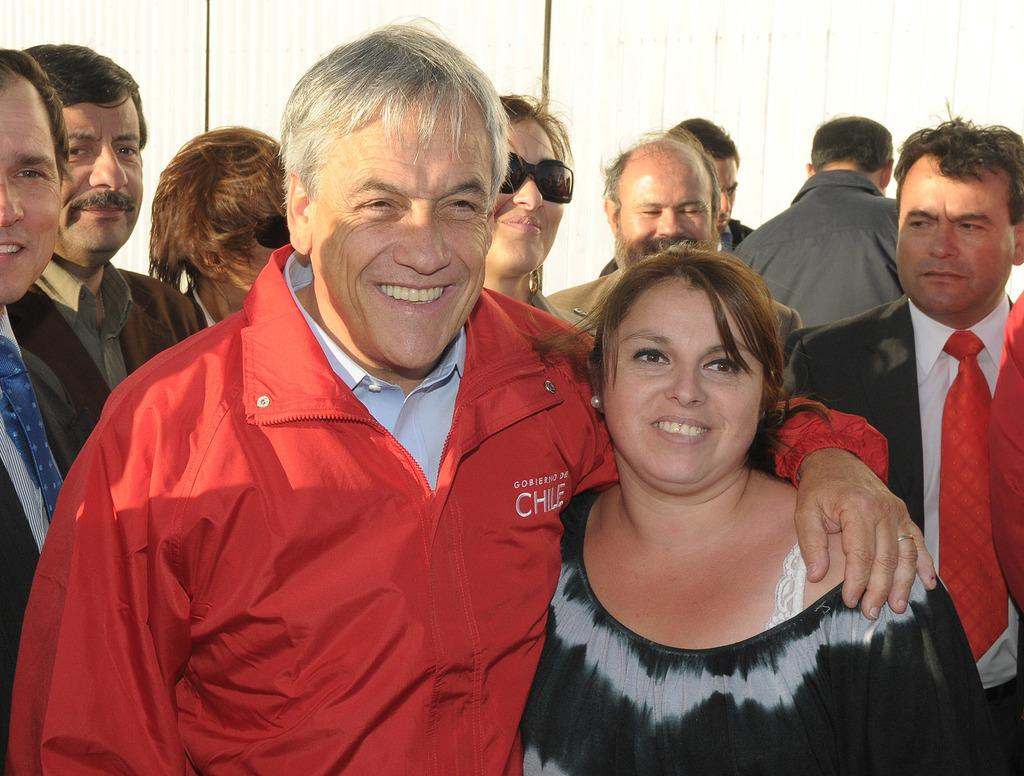What is happening in the image? There are people standing in the image. Can you describe the facial expression of one of the individuals? A man is smiling in the image. What color is the background of the image? The background of the image is white. What type of root can be seen growing in the image? There is no root present in the image; it features people standing against a white background. What event is taking place in the image? There is no specific event depicted in the image; it simply shows people standing. 